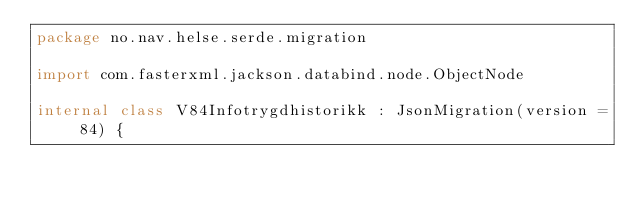Convert code to text. <code><loc_0><loc_0><loc_500><loc_500><_Kotlin_>package no.nav.helse.serde.migration

import com.fasterxml.jackson.databind.node.ObjectNode

internal class V84Infotrygdhistorikk : JsonMigration(version = 84) {</code> 